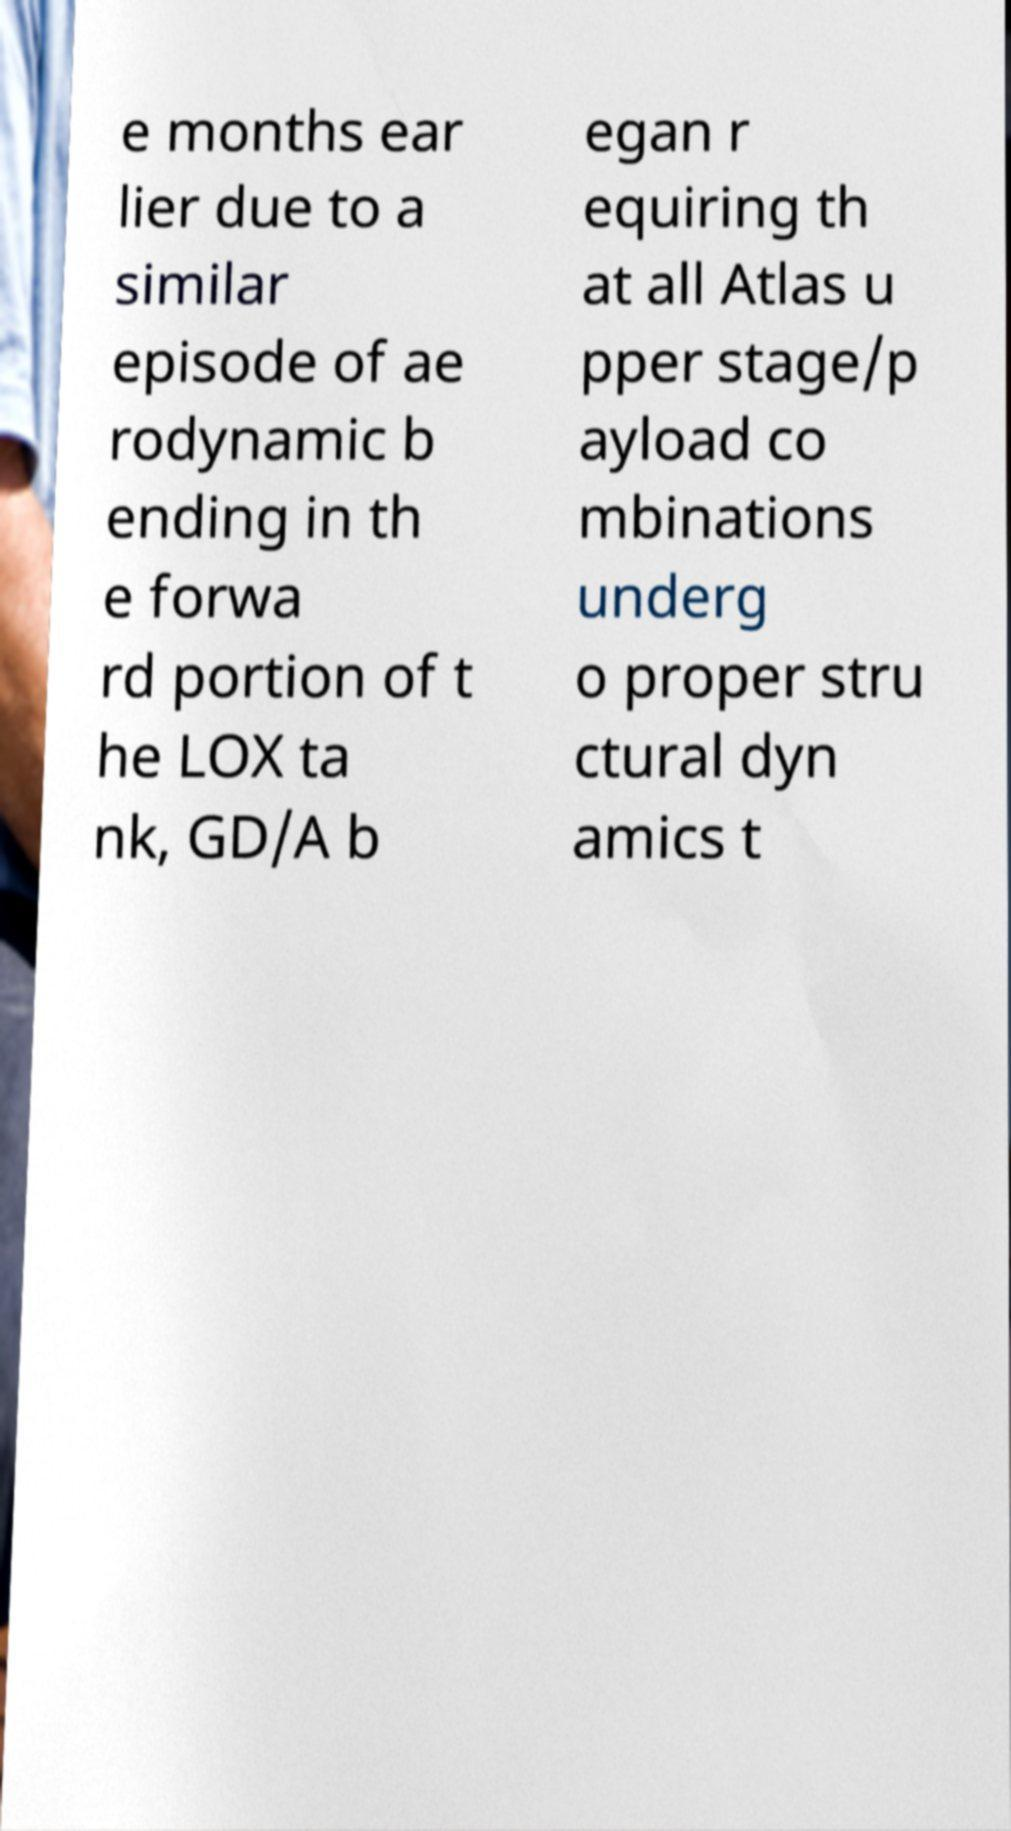Can you accurately transcribe the text from the provided image for me? e months ear lier due to a similar episode of ae rodynamic b ending in th e forwa rd portion of t he LOX ta nk, GD/A b egan r equiring th at all Atlas u pper stage/p ayload co mbinations underg o proper stru ctural dyn amics t 